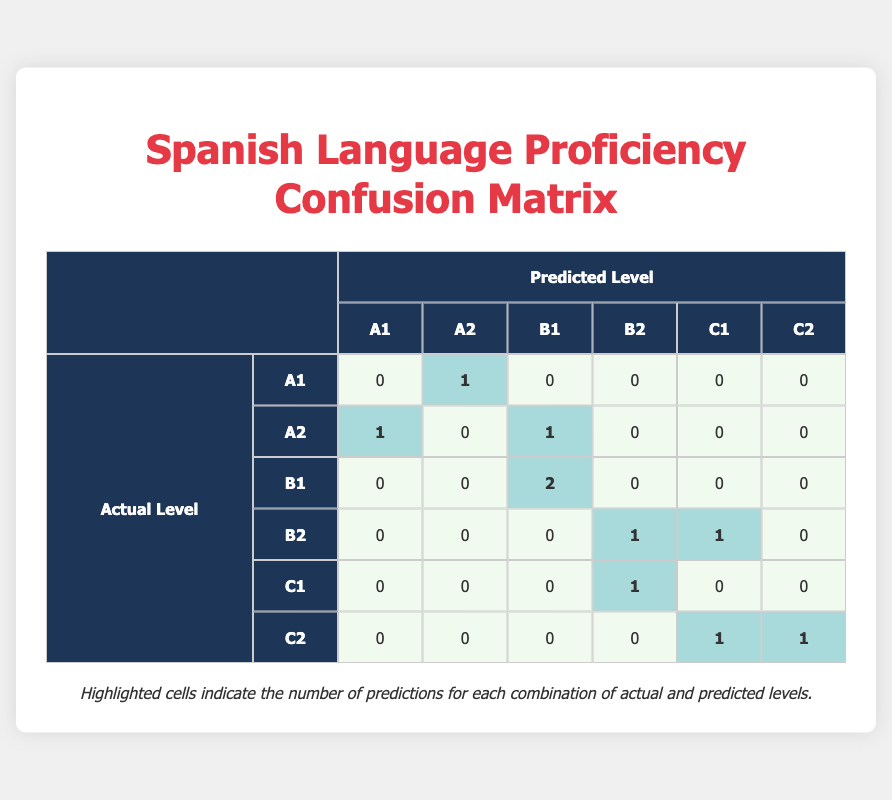What is the predicted level for the student named Diego Fernández? In the table, I can locate Diego Fernández in the list of students. His predicted level is listed under the "Predicted Level" column, which states B1.
Answer: B1 How many students were accurately predicted at the B1 level? To find this, I will look at the row for actual level B1 and count how many times the predicted level also shows B1. The count is 2 (Diego Fernández and Gabriel Morales).
Answer: 2 Is there any student whose predicted level is C1 and actual level is A1? I can check the table for any entries with a predicted level of C1 and then see if the actual level for those students shows A1. There are no students fitting that description in the table.
Answer: No What is the total number of students predicted to be at the A2 level? To answer this, I will examine the "Predicted Level" column and count how many times A2 appears. It appears 2 times (Lucas Martinez and Isabella Castro).
Answer: 2 Are there more students predicted to be at B2 than at C2? To answer this, I will count the number of students predicted at B2 (which is 1) and compare it with the number predicted at C2 (which is 2). Since 1 is not greater than 2, the answer is no.
Answer: No How many students have an actual level of C1? I will look at the "Actual Level" row for C1 and count the corresponding entries. There is 1 student who has an actual level of C1 (Maria Delgado).
Answer: 1 What is the percentage of correct predictions for the total number of students? First, I need to identify the total number of students, which is 10. Then, I check for correct predictions which are Sofia Lopez, Diego Fernández, and Nicolas Torres. That gives us 3 correct predictions out of 10 students, or 30%.
Answer: 30% What is the difference between the number of students predicted at B1 and B2? For this, I will count the entries for the predicted levels of B1, which is 3 (Diego Fernández, Gabriel Morales, and one B1 that was misclassified), and B2, which is 3 as well. The difference between them is 0.
Answer: 0 Which actual language level had the highest number of incorrect predictions? I will look at each actual language level's row and determine the count of incorrect predictions. The actual level B2 had 2 incorrect predictions (Camila Gonzalez and Valentina Ramirez). I'll compare and find that it has the highest count.
Answer: B2 